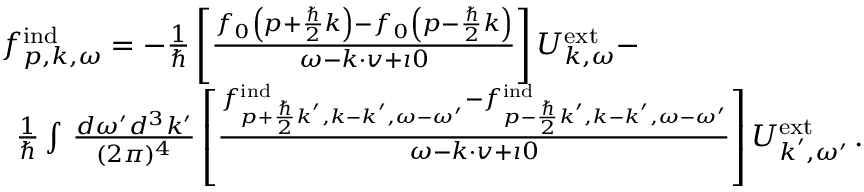<formula> <loc_0><loc_0><loc_500><loc_500>\begin{array} { r l } & { f _ { p , k , \omega } ^ { i n d } = - \frac { 1 } { } \left [ \frac { f _ { 0 } \left ( p + \frac { } { 2 } k \right ) - f _ { 0 } \left ( p - \frac { } { 2 } k \right ) } { \omega - k \cdot v + \imath 0 } \right ] { U } _ { k , \omega } ^ { e x t } - } \\ & { \, \frac { 1 } { } \int \, \frac { d \omega ^ { \prime } d ^ { 3 } k ^ { \prime } } { ( 2 \pi ) ^ { 4 } } \left [ \frac { f _ { p + \frac { } { 2 } k ^ { \prime } , k - k ^ { \prime } , \omega - \omega ^ { \prime } } ^ { i n d } - f _ { p - \frac { } { 2 } k ^ { \prime } , k - k ^ { \prime } , \omega - \omega ^ { \prime } } ^ { i n d } } { \omega - k \cdot v + \imath 0 } \right ] { U } _ { k ^ { \prime } , \omega ^ { \prime } } ^ { e x t } \, . } \end{array}</formula> 